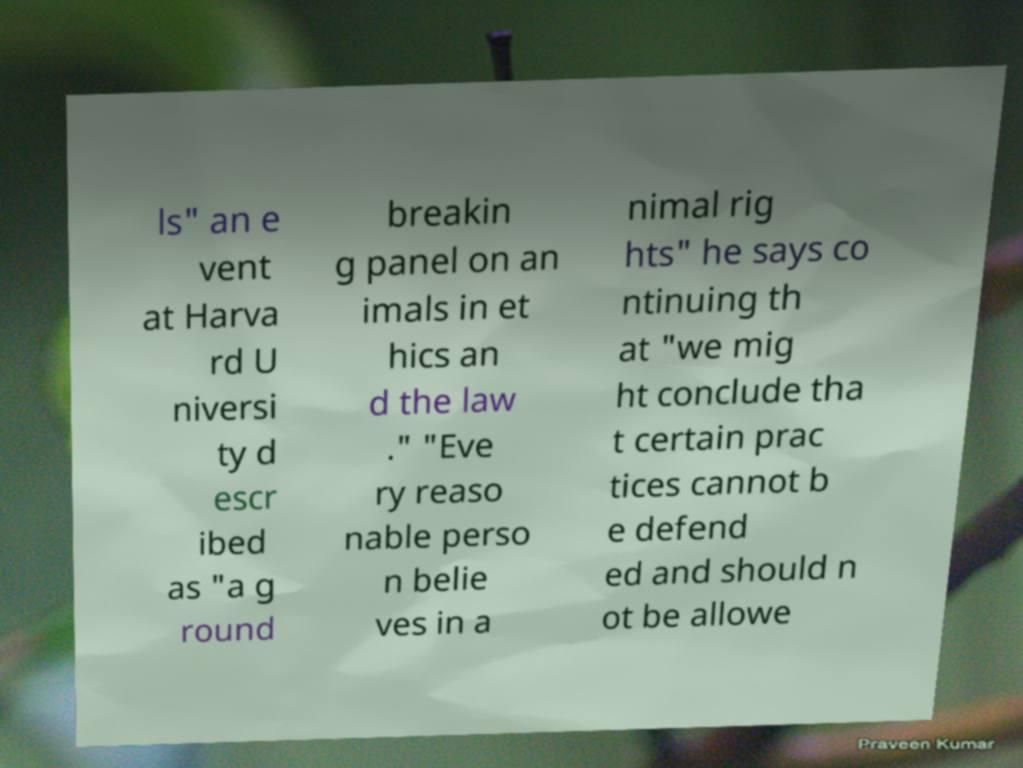What messages or text are displayed in this image? I need them in a readable, typed format. ls" an e vent at Harva rd U niversi ty d escr ibed as "a g round breakin g panel on an imals in et hics an d the law ." "Eve ry reaso nable perso n belie ves in a nimal rig hts" he says co ntinuing th at "we mig ht conclude tha t certain prac tices cannot b e defend ed and should n ot be allowe 